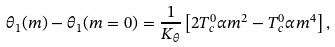Convert formula to latex. <formula><loc_0><loc_0><loc_500><loc_500>\theta _ { 1 } ( m ) - \theta _ { 1 } ( m = 0 ) = \frac { 1 } { K _ { \theta } } \left [ 2 T _ { c } ^ { 0 } \alpha m ^ { 2 } - T _ { c } ^ { 0 } \alpha m ^ { 4 } \right ] ,</formula> 